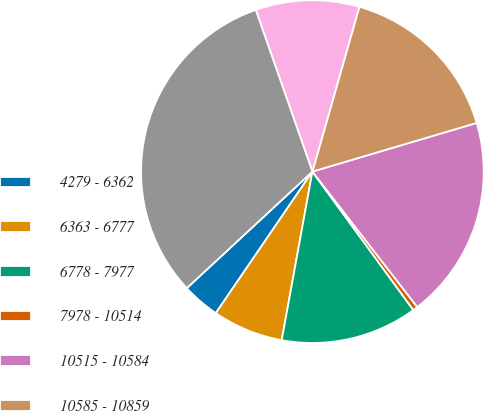<chart> <loc_0><loc_0><loc_500><loc_500><pie_chart><fcel>4279 - 6362<fcel>6363 - 6777<fcel>6778 - 7977<fcel>7978 - 10514<fcel>10515 - 10584<fcel>10585 - 10859<fcel>10860 - 14965<fcel>Total<nl><fcel>3.56%<fcel>6.67%<fcel>12.89%<fcel>0.46%<fcel>19.1%<fcel>16.0%<fcel>9.78%<fcel>31.54%<nl></chart> 